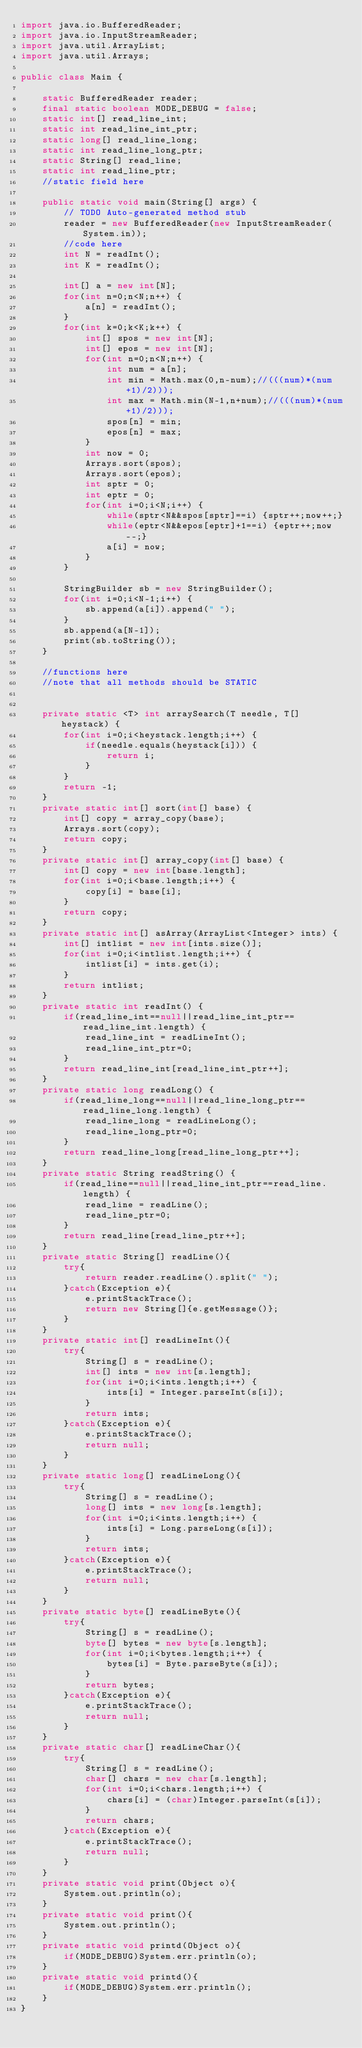<code> <loc_0><loc_0><loc_500><loc_500><_Java_>import java.io.BufferedReader;
import java.io.InputStreamReader;
import java.util.ArrayList;
import java.util.Arrays;

public class Main {

	static BufferedReader reader;
	final static boolean MODE_DEBUG = false;
	static int[] read_line_int;
	static int read_line_int_ptr;
	static long[] read_line_long;
	static int read_line_long_ptr;
	static String[] read_line;
	static int read_line_ptr;
	//static field here
	
	public static void main(String[] args) {
		// TODO Auto-generated method stub
		reader = new BufferedReader(new InputStreamReader(System.in));
		//code here
		int N = readInt();
		int K = readInt();
		
		int[] a = new int[N];
		for(int n=0;n<N;n++) {
			a[n] = readInt();
		}
		for(int k=0;k<K;k++) {
			int[] spos = new int[N];
			int[] epos = new int[N];
			for(int n=0;n<N;n++) {
				int num = a[n];
				int min = Math.max(0,n-num);//(((num)*(num+1)/2)));
				int max = Math.min(N-1,n+num);//(((num)*(num+1)/2)));
				spos[n] = min;
				epos[n] = max;
			}
			int now = 0;
			Arrays.sort(spos);
			Arrays.sort(epos);
			int sptr = 0;
			int eptr = 0;
			for(int i=0;i<N;i++) {
				while(sptr<N&&spos[sptr]==i) {sptr++;now++;}
				while(eptr<N&&epos[eptr]+1==i) {eptr++;now--;}
				a[i] = now;
			}
		}
		
		StringBuilder sb = new StringBuilder();
		for(int i=0;i<N-1;i++) {
			sb.append(a[i]).append(" ");
		}
		sb.append(a[N-1]);
		print(sb.toString());
	}
	
	//functions here
	//note that all methods should be STATIC


	private static <T> int arraySearch(T needle, T[] heystack) {
		for(int i=0;i<heystack.length;i++) {
			if(needle.equals(heystack[i])) {
				return i;
			}
		}
		return -1;
	}
	private static int[] sort(int[] base) {
		int[] copy = array_copy(base);
		Arrays.sort(copy);
		return copy;
	}
	private static int[] array_copy(int[] base) {
		int[] copy = new int[base.length];
		for(int i=0;i<base.length;i++) {
			copy[i] = base[i];
		}
		return copy;
	}
	private static int[] asArray(ArrayList<Integer> ints) {
		int[] intlist = new int[ints.size()];
		for(int i=0;i<intlist.length;i++) {
			intlist[i] = ints.get(i);
		}
		return intlist;
	}
	private static int readInt() {
		if(read_line_int==null||read_line_int_ptr==read_line_int.length) {
			read_line_int = readLineInt();
			read_line_int_ptr=0;
		}
		return read_line_int[read_line_int_ptr++];
	}
	private static long readLong() {
		if(read_line_long==null||read_line_long_ptr==read_line_long.length) {
			read_line_long = readLineLong();
			read_line_long_ptr=0;
		}
		return read_line_long[read_line_long_ptr++];
	}
	private static String readString() {
		if(read_line==null||read_line_int_ptr==read_line.length) {
			read_line = readLine();
			read_line_ptr=0;
		}
		return read_line[read_line_ptr++];
	}
	private static String[] readLine(){
		try{
			return reader.readLine().split(" ");
		}catch(Exception e){
			e.printStackTrace();
			return new String[]{e.getMessage()};
		}
	}
	private static int[] readLineInt(){
		try{
			String[] s = readLine();
			int[] ints = new int[s.length];
			for(int i=0;i<ints.length;i++) {
				ints[i] = Integer.parseInt(s[i]);
			}
			return ints;
		}catch(Exception e){
			e.printStackTrace();
			return null;
		}
	}
	private static long[] readLineLong(){
		try{
			String[] s = readLine();
			long[] ints = new long[s.length];
			for(int i=0;i<ints.length;i++) {
				ints[i] = Long.parseLong(s[i]);
			}
			return ints;
		}catch(Exception e){
			e.printStackTrace();
			return null;
		}
	}
	private static byte[] readLineByte(){
		try{
			String[] s = readLine();
			byte[] bytes = new byte[s.length];
			for(int i=0;i<bytes.length;i++) {
				bytes[i] = Byte.parseByte(s[i]);
			}
			return bytes;
		}catch(Exception e){
			e.printStackTrace();
			return null;
		}
	}
	private static char[] readLineChar(){
		try{
			String[] s = readLine();
			char[] chars = new char[s.length];
			for(int i=0;i<chars.length;i++) {
				chars[i] = (char)Integer.parseInt(s[i]);
			}
			return chars;
		}catch(Exception e){
			e.printStackTrace();
			return null;
		}
	}
	private static void print(Object o){
		System.out.println(o);
	}
	private static void print(){
		System.out.println();
	}
	private static void printd(Object o){
		if(MODE_DEBUG)System.err.println(o);
	}
	private static void printd(){
		if(MODE_DEBUG)System.err.println();
	}
}
</code> 